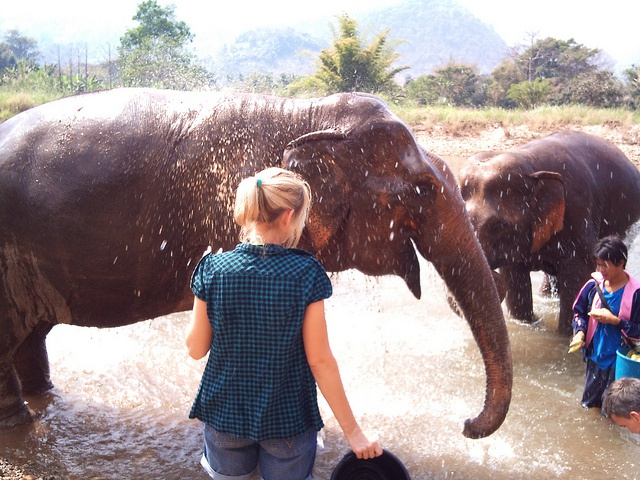Describe the objects in this image and their specific colors. I can see elephant in white, maroon, black, and brown tones, people in white, black, navy, blue, and salmon tones, elephant in white, black, maroon, and purple tones, people in white, black, navy, brown, and gray tones, and people in white, gray, brown, darkgray, and maroon tones in this image. 